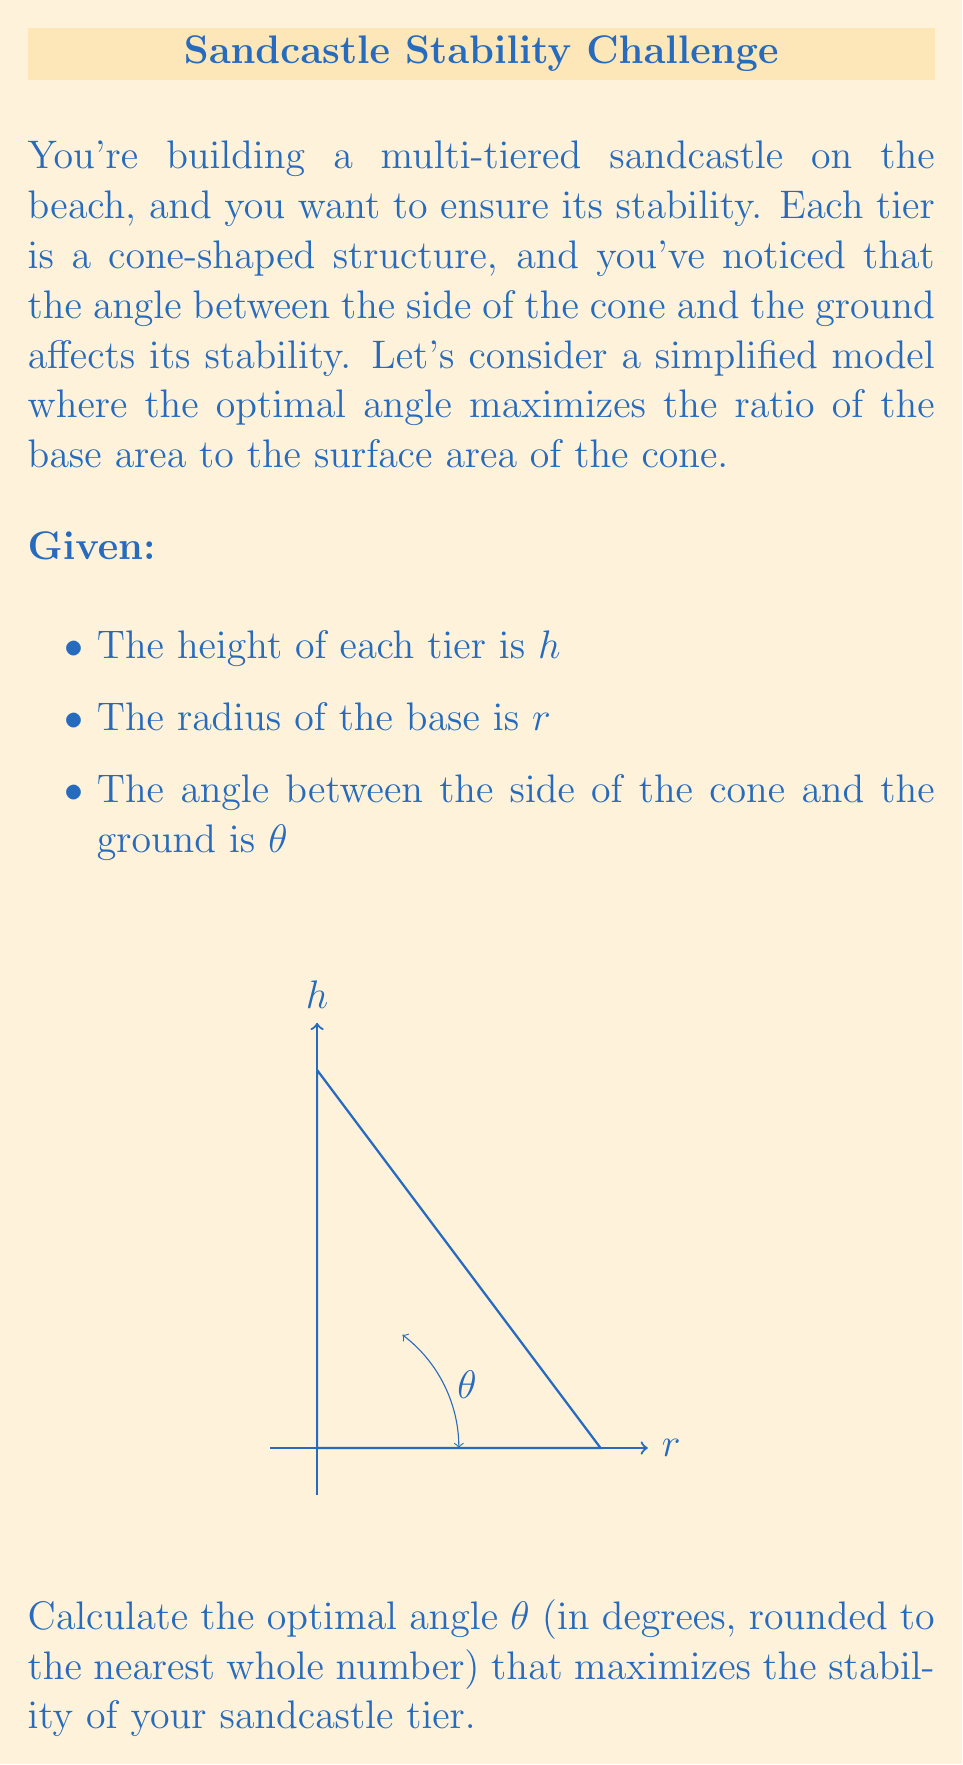Show me your answer to this math problem. Let's approach this step-by-step:

1) First, we need to express the surface area and base area in terms of $r$, $h$, and $\theta$.

2) The base area is simple: $A_{base} = \pi r^2$

3) The surface area (excluding the base) is: $A_{surface} = \pi r s$, where $s$ is the slant height.

4) We can express $r$ and $s$ in terms of $h$ and $\theta$:
   $r = h \tan \theta$
   $s = \frac{h}{\cos \theta}$

5) Now, we want to maximize the ratio: $\frac{A_{base}}{A_{surface}} = \frac{\pi r^2}{\pi r s} = \frac{r}{s}$

6) Substituting our expressions for $r$ and $s$:

   $$\frac{r}{s} = \frac{h \tan \theta}{\frac{h}{\cos \theta}} = \sin \theta$$

7) Therefore, maximizing $\frac{r}{s}$ is equivalent to maximizing $\sin \theta$.

8) We know that $\sin \theta$ reaches its maximum value of 1 when $\theta = 90°$. However, this would result in a flat disk, not a cone.

9) The next best angle is 45°, which gives a balance between height and base width.

10) At 45°, $\sin \theta = \frac{\sqrt{2}}{2} \approx 0.707$, which is reasonably close to the maximum of 1.

Therefore, the optimal angle for stability is approximately 45°.
Answer: 45° 